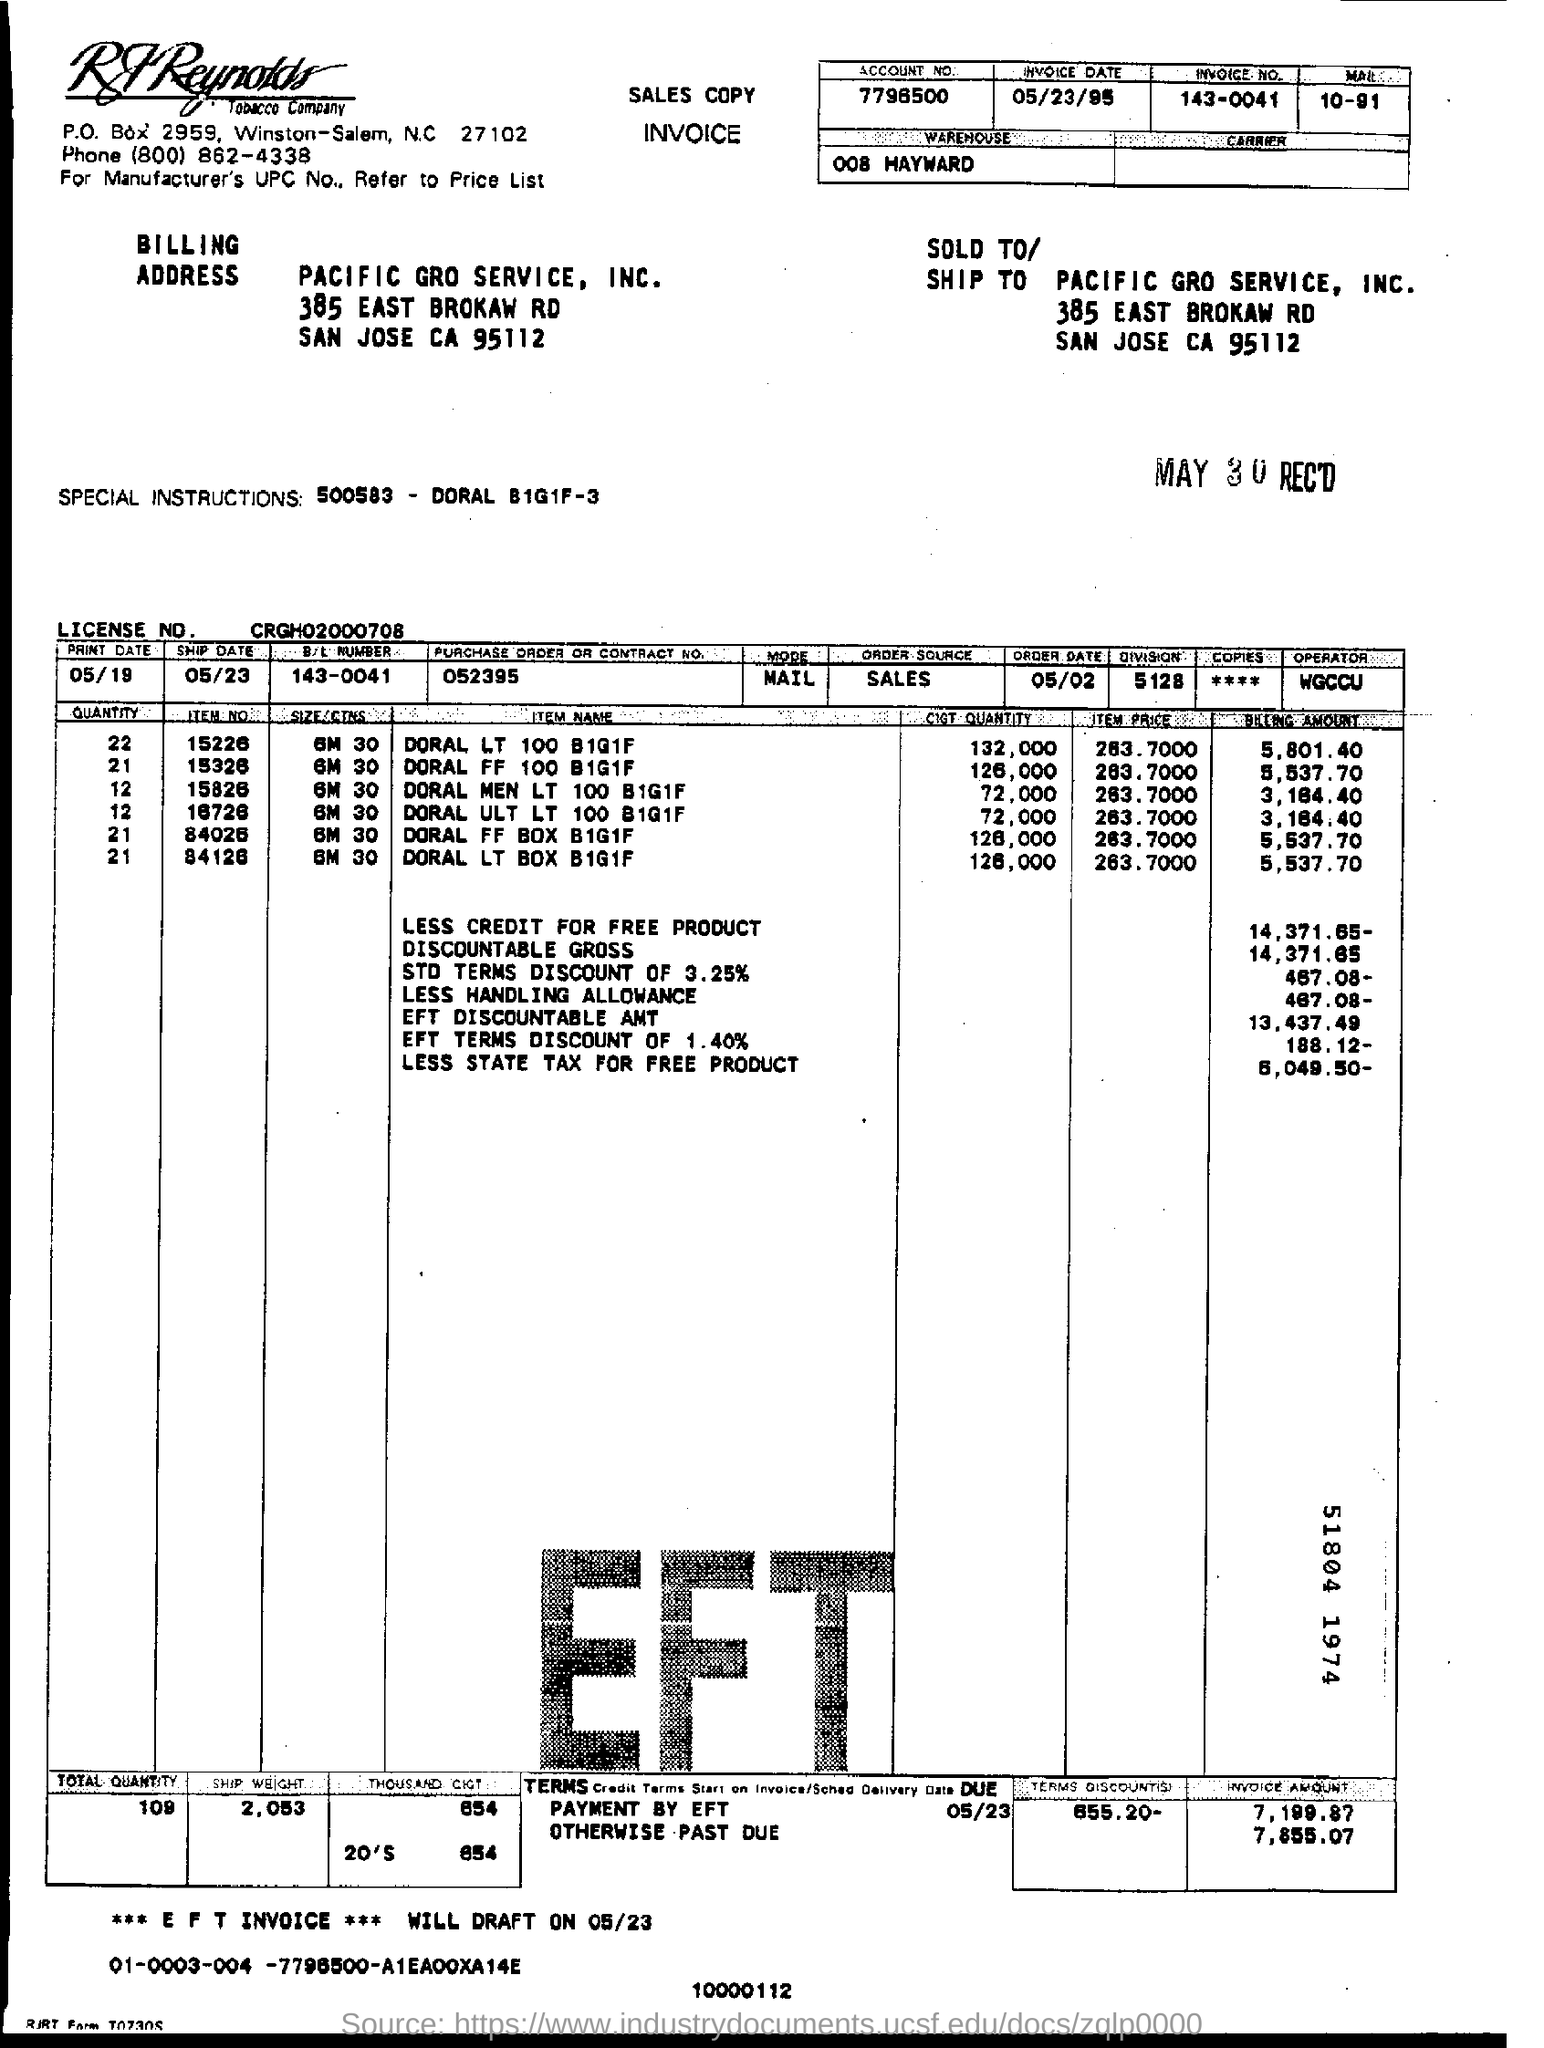What is the invoice number given?
Ensure brevity in your answer.  143-0041. What is the account no given in the invoice?
Your response must be concise. 7796500. Whats the license no.?
Ensure brevity in your answer.  CRGH02000708. Whats the Contract No. or PURCHASE  ORDER?
Provide a short and direct response. 052395. Name the largest QUANTITY of ITEM  purchased?
Ensure brevity in your answer.  DORAL LT 100 B1G1F. What is the quantity of the item name 'DORAL MEN LT 100B1G1F'?
Your answer should be very brief. 12. Price of all the items were same. State whether True or Flase.
Keep it short and to the point. True. Whats the Weight of total items (SHIP WEIGHT) ?
Ensure brevity in your answer.  2.053. Mention the NO. of TERMS DISCOUNT ?
Offer a terse response. 655.20-. 